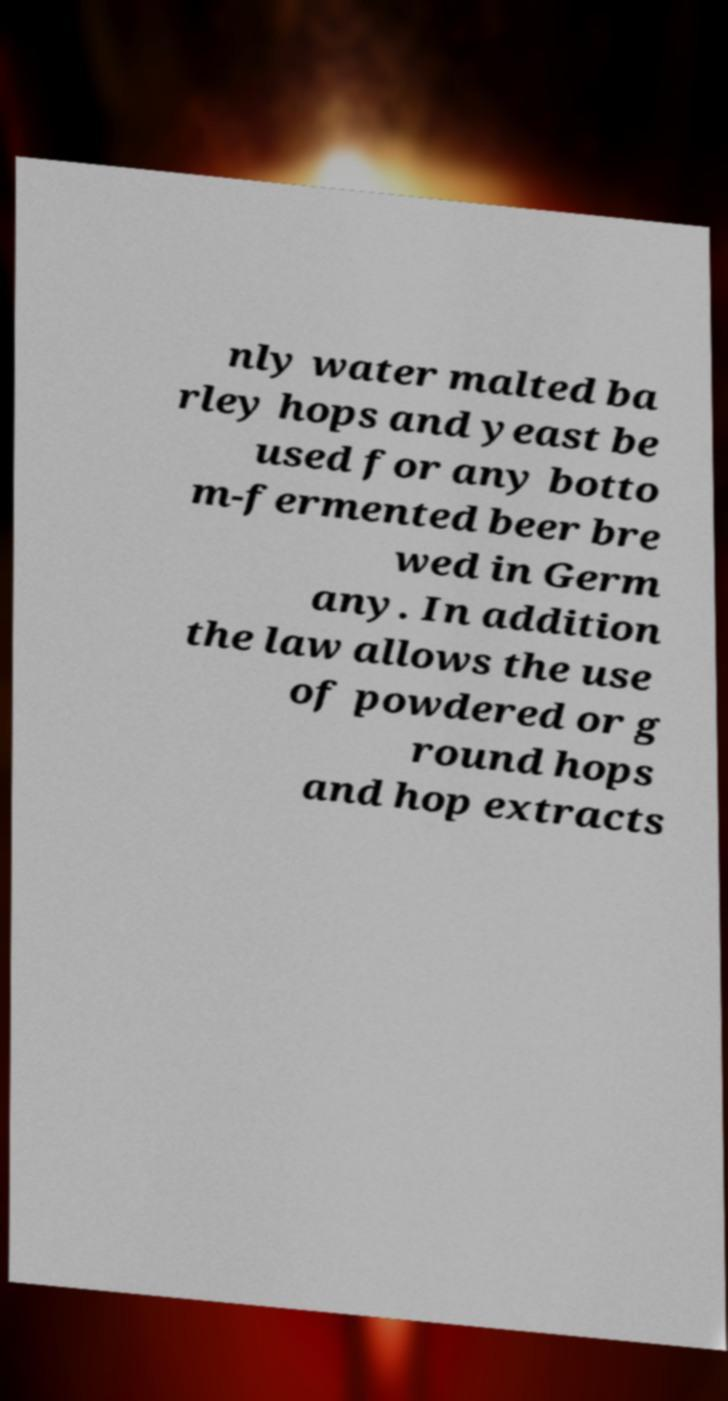There's text embedded in this image that I need extracted. Can you transcribe it verbatim? nly water malted ba rley hops and yeast be used for any botto m-fermented beer bre wed in Germ any. In addition the law allows the use of powdered or g round hops and hop extracts 